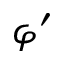<formula> <loc_0><loc_0><loc_500><loc_500>\varphi ^ { \prime }</formula> 